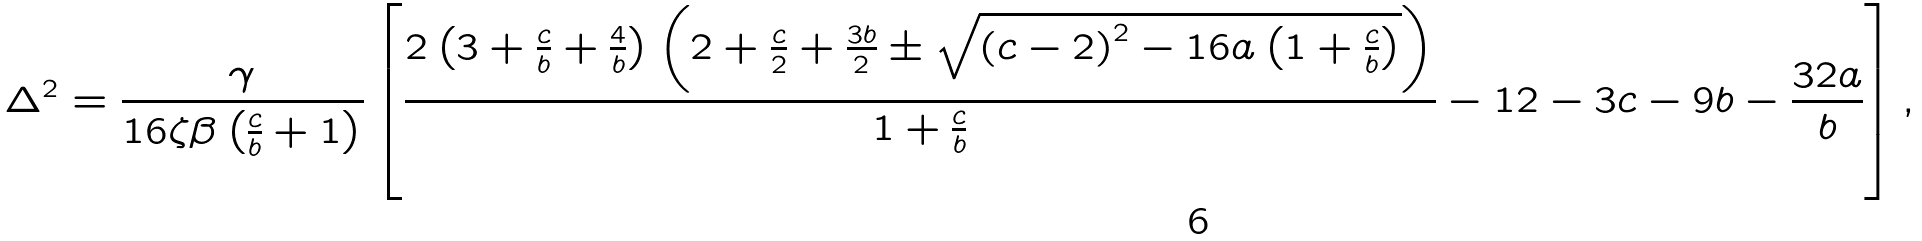<formula> <loc_0><loc_0><loc_500><loc_500>\Delta ^ { 2 } = \frac { \gamma } { { 1 6 \zeta \beta \left ( { \frac { c } { b } + 1 } \right ) } } \left [ { \frac { { 2 \left ( { 3 + \frac { c } { b } + \frac { 4 } { b } } \right ) \left ( { 2 + \frac { c } { 2 } + \frac { 3 b } { 2 } \pm \sqrt { \left ( { c - 2 } \right ) ^ { 2 } - 1 6 a \left ( { 1 + \frac { c } { b } } \right ) } } \right ) } } { { 1 + \frac { c } { b } } } - 1 2 - 3 c - 9 b - \frac { 3 2 a } { b } } \right ] ,</formula> 